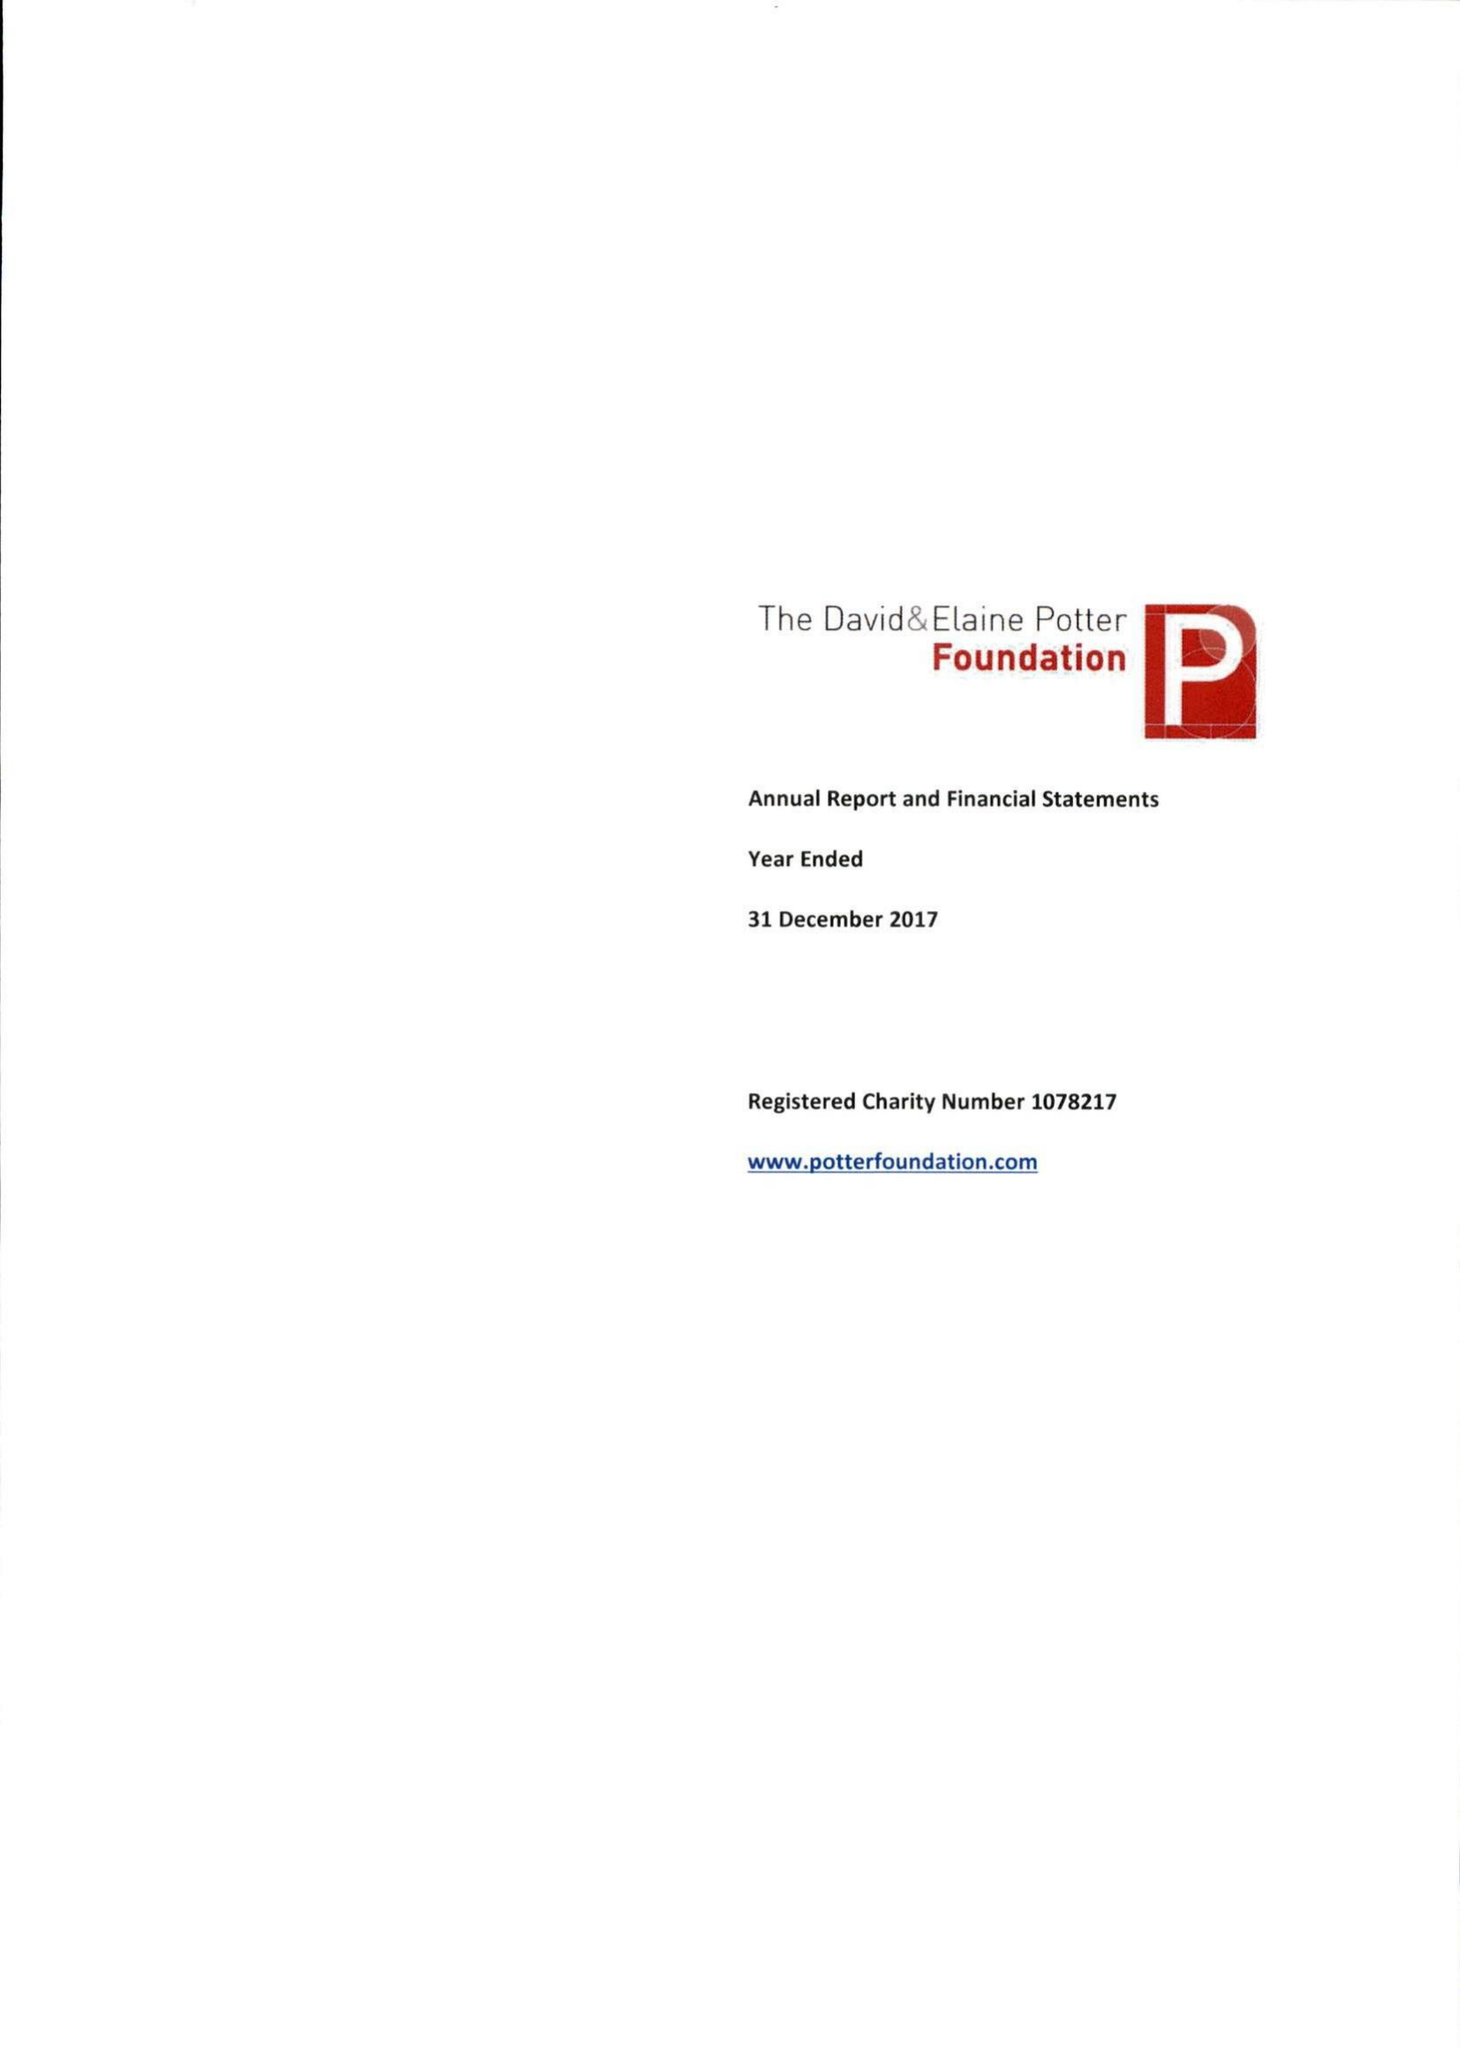What is the value for the income_annually_in_british_pounds?
Answer the question using a single word or phrase. 345880.00 